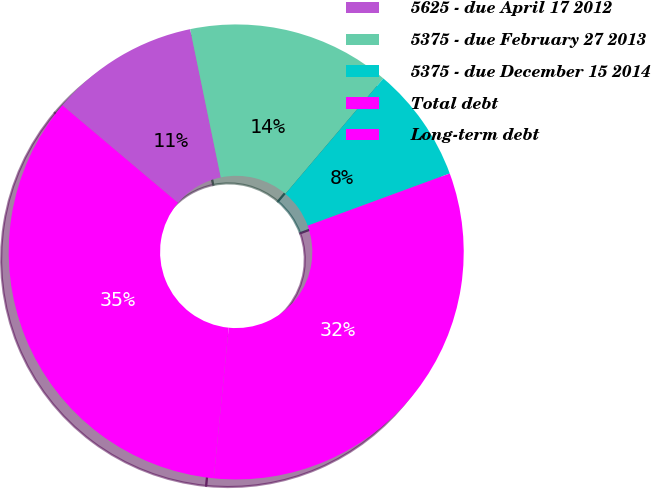<chart> <loc_0><loc_0><loc_500><loc_500><pie_chart><fcel>5625 - due April 17 2012<fcel>5375 - due February 27 2013<fcel>5375 - due December 15 2014<fcel>Total debt<fcel>Long-term debt<nl><fcel>10.6%<fcel>14.44%<fcel>8.2%<fcel>32.18%<fcel>34.58%<nl></chart> 